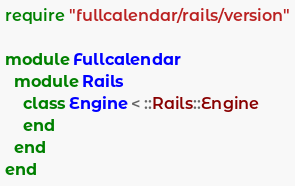Convert code to text. <code><loc_0><loc_0><loc_500><loc_500><_Ruby_>require "fullcalendar/rails/version"

module Fullcalendar
  module Rails
    class Engine < ::Rails::Engine
    end
  end
end
</code> 